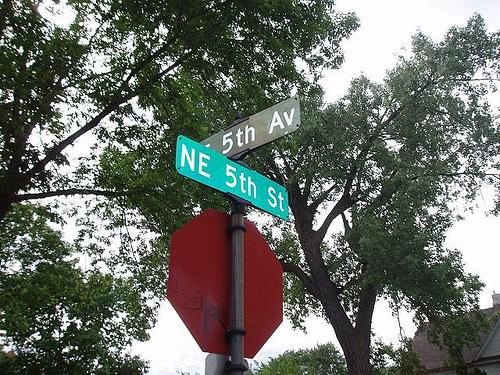What do you do at this kind of sign?
Concise answer only. Stop. How many red signs are posted?
Give a very brief answer. 1. What number do these two signs have in common?
Be succinct. 5. What intersection is this?
Concise answer only. 5th and 5th. 